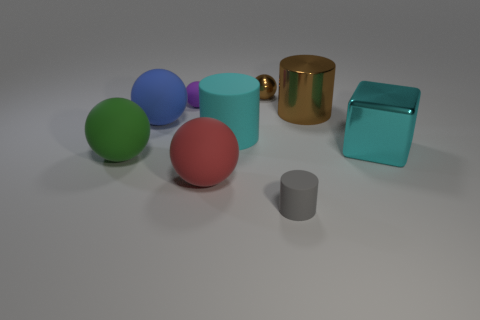Subtract 1 balls. How many balls are left? 4 Subtract all brown shiny cylinders. How many cylinders are left? 2 Subtract all brown spheres. How many spheres are left? 4 Subtract all blue spheres. Subtract all blue cylinders. How many spheres are left? 4 Subtract all balls. How many objects are left? 4 Add 5 purple cylinders. How many purple cylinders exist? 5 Subtract 0 cyan balls. How many objects are left? 9 Subtract all large cylinders. Subtract all gray rubber cylinders. How many objects are left? 6 Add 7 small gray objects. How many small gray objects are left? 8 